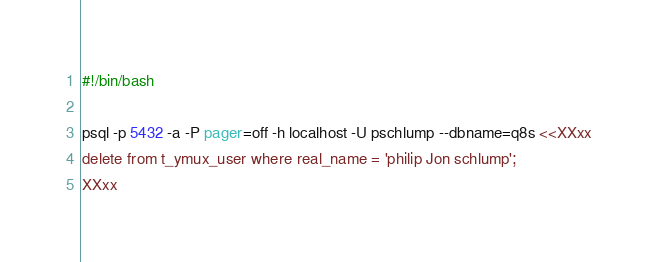Convert code to text. <code><loc_0><loc_0><loc_500><loc_500><_Bash_>#!/bin/bash

psql -p 5432 -a -P pager=off -h localhost -U pschlump --dbname=q8s <<XXxx
delete from t_ymux_user where real_name = 'philip Jon schlump';
XXxx
</code> 